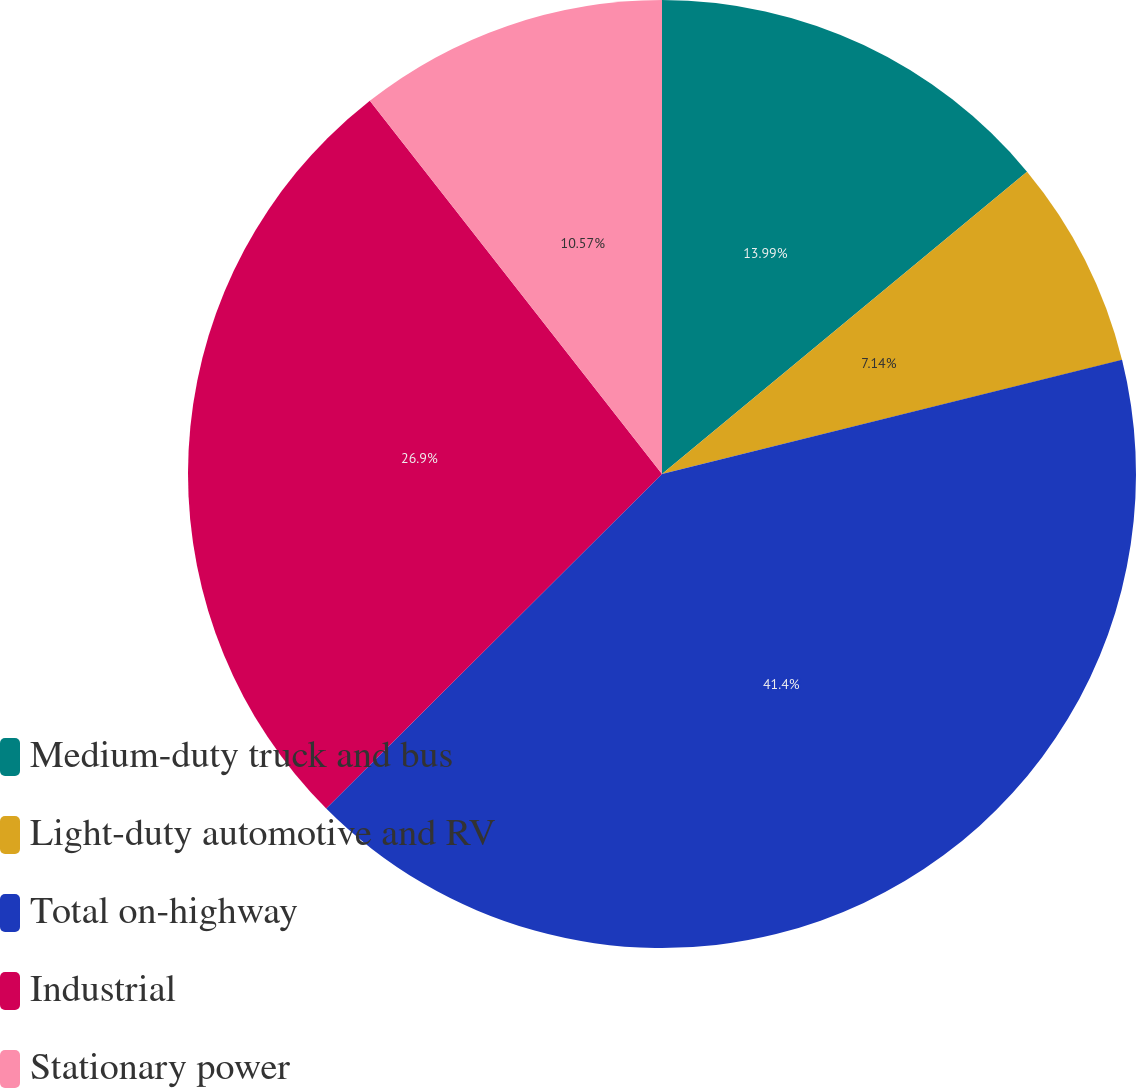<chart> <loc_0><loc_0><loc_500><loc_500><pie_chart><fcel>Medium-duty truck and bus<fcel>Light-duty automotive and RV<fcel>Total on-highway<fcel>Industrial<fcel>Stationary power<nl><fcel>13.99%<fcel>7.14%<fcel>41.4%<fcel>26.9%<fcel>10.57%<nl></chart> 